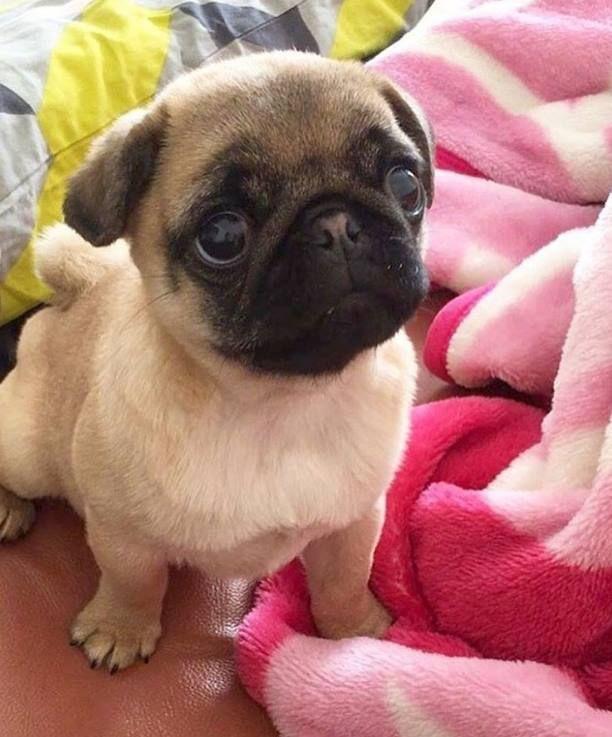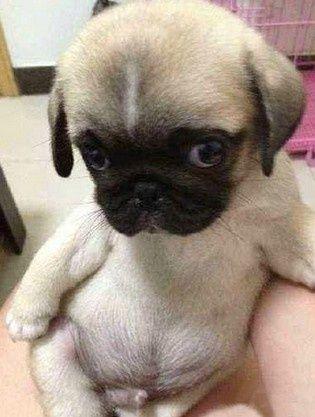The first image is the image on the left, the second image is the image on the right. Examine the images to the left and right. Is the description "The dog in the image on the left is on a pink piece of material." accurate? Answer yes or no. Yes. 